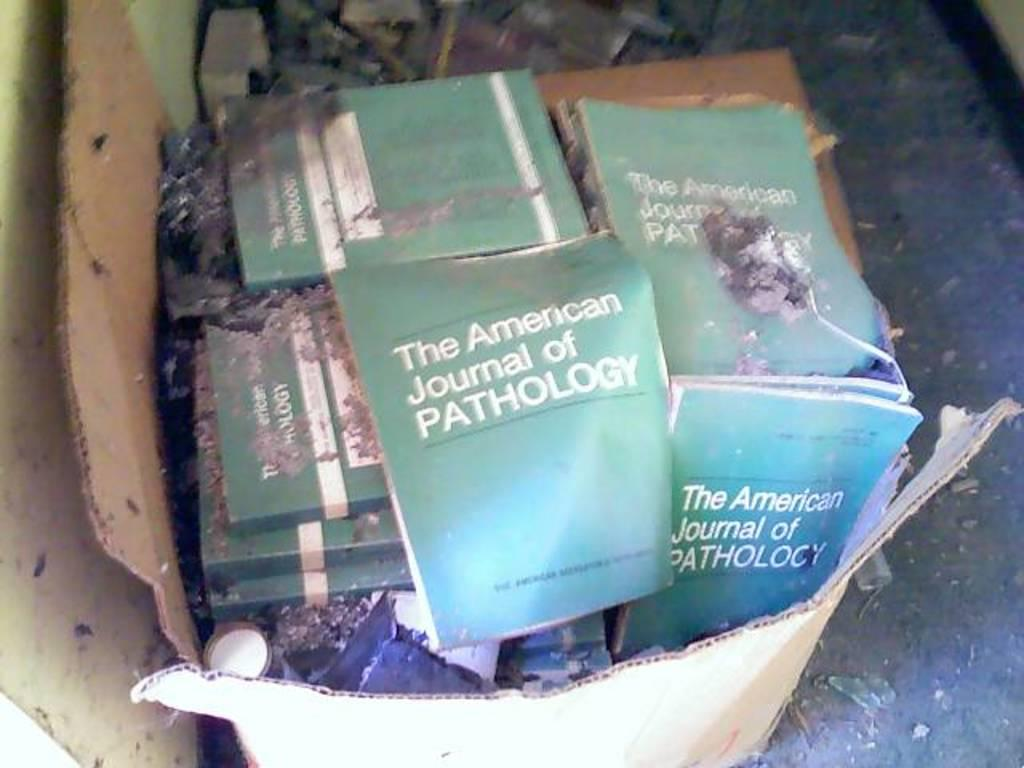<image>
Describe the image concisely. A torn cardboard box contains many copies of "The American Journal of Pathology". 